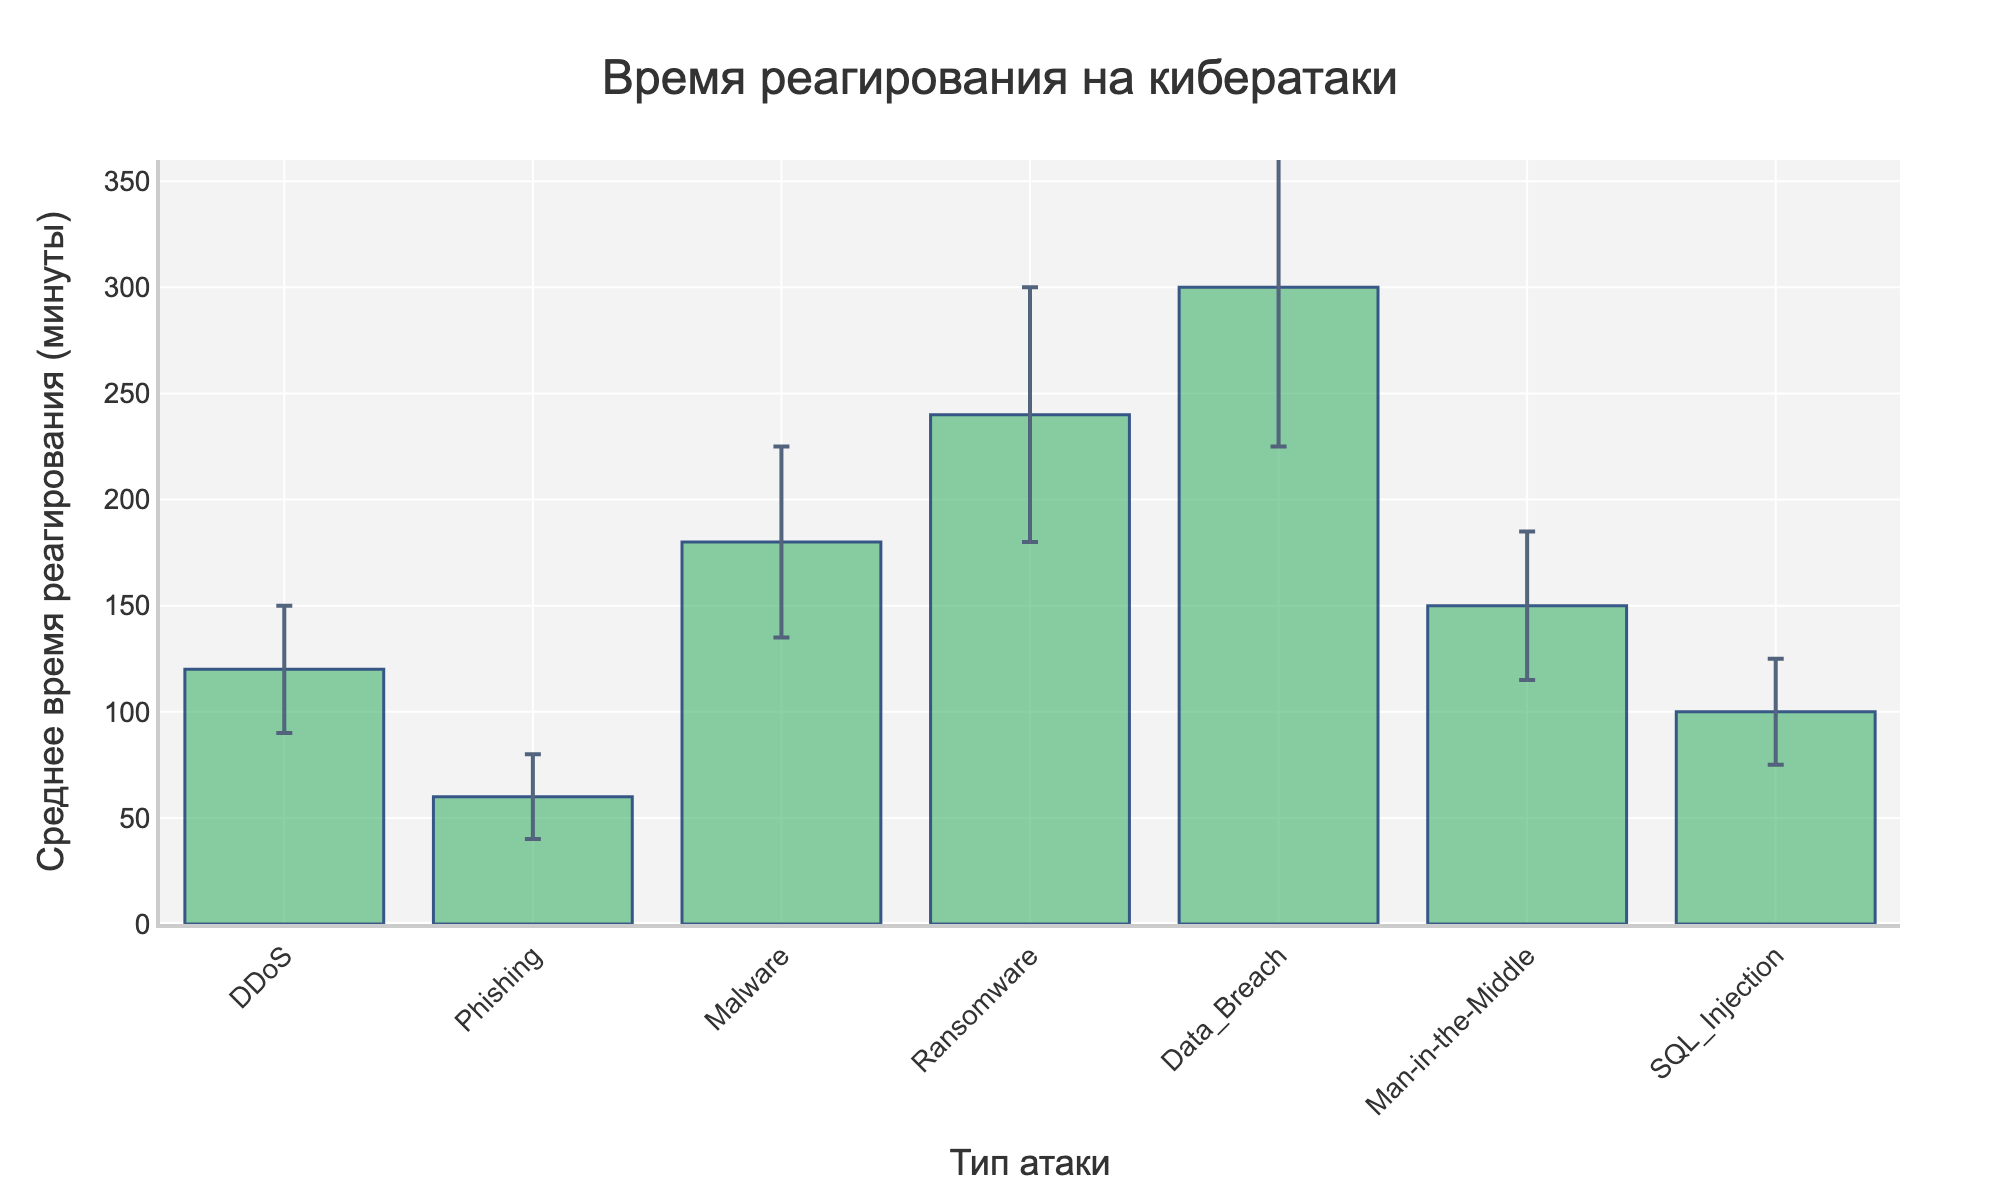What is the average response time for a DDoS attack? The bar for DDoS shows an average response time of 120 minutes.
Answer: 120 minutes Which type of attack has the highest average response time? The bar represents the 'Data_Breach' attack with the highest average response time of 300 minutes.
Answer: Data_Breach How much longer is the response time for a Data Breach compared to a DDoS attack? Calculating the difference between the average response times for Data Breach (300 minutes) and DDoS (120 minutes): 300 - 120 = 180 minutes.
Answer: 180 minutes What is the range of average response times shown in the figure? The lowest average response time is for Phishing (60 minutes) and the highest is for Data Breach (300 minutes). Therefore, the range is 300 - 60 = 240 minutes.
Answer: 240 minutes Which attack types have an average response time of more than 200 minutes? The bars for Ransomware (240 minutes) and Data Breach (300 minutes) have average response times greater than 200 minutes.
Answer: Ransomware, Data_Breach What is the average response time for SQL Injection attacks, and what is its standard deviation? The bar for SQL Injection shows an average response time of 100 minutes with an error bar (standard deviation) of 25 minutes.
Answer: 100 minutes, 25 minutes What is the average difference in response times between Ransomware and Malware attacks? Subtracting the average response time of Malware (180 minutes) from that of Ransomware (240 minutes): 240 - 180 = 60 minutes.
Answer: 60 minutes Which attack type has an average response time closest to 2 hours? The bar closest to 120 minutes (2 hours) is DDoS which has an average response time of 120 minutes.
Answer: DDoS What is the average response time for Man-in-the-Middle attacks, and how does it compare to that of SQL Injection attacks? The average response time for Man-in-the-Middle is 150 minutes, while that for SQL Injection is 100 minutes. The difference is 150 - 100 = 50 minutes, with Man-in-the-Middle being 50 minutes longer.
Answer: Man-in-the-Middle: 150 minutes, SQL Injection: 100 minutes; Difference: 50 minutes How does the standard deviation for Phishing attacks compare to that for Data Breach attacks? The standard deviation for Phishing is 20 minutes, whereas for Data Breach it's 75 minutes. The difference is 75 - 20 = 55 minutes, with Data Breach having a higher standard deviation by 55 minutes.
Answer: Phishing: 20 minutes, Data Breach: 75 minutes; Difference: 55 minutes 